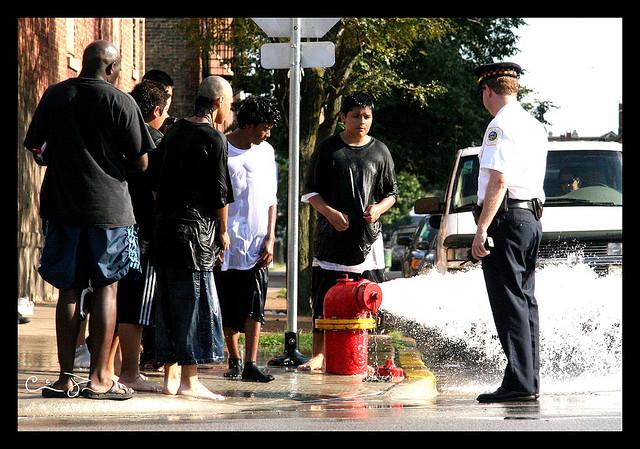Are they all showering?
Short answer required. No. What substance is covering the white shirts in this photo?
Give a very brief answer. Water. Who is in front of the hydrant?
Keep it brief. Police officer. How many people do you see?
Quick response, please. 7. 